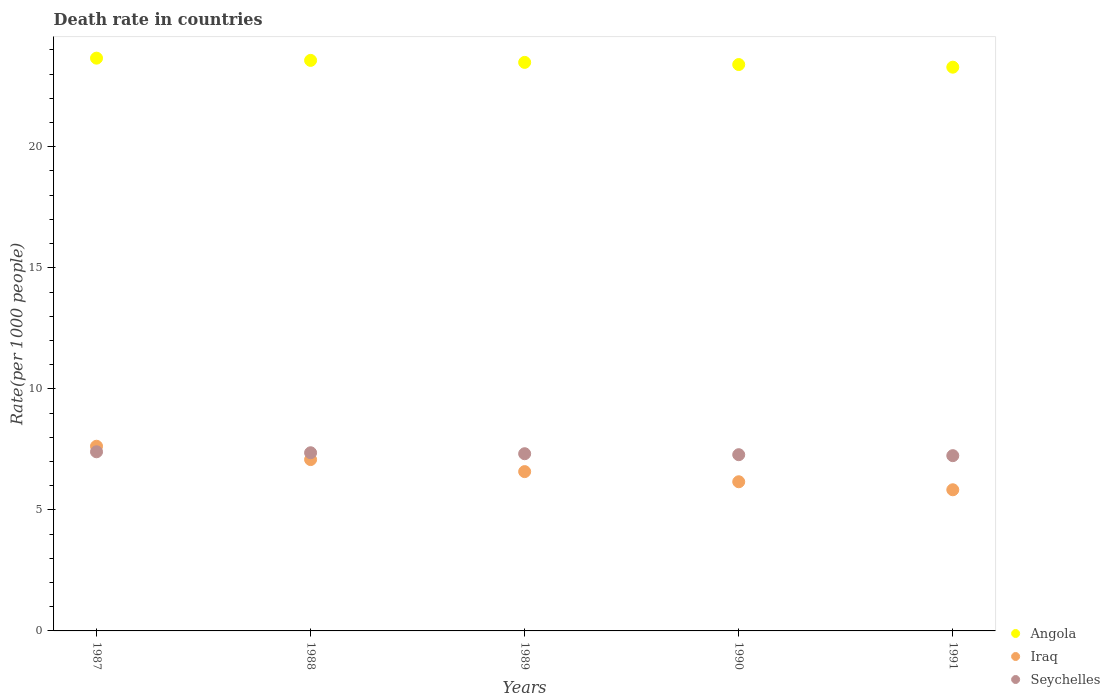Is the number of dotlines equal to the number of legend labels?
Your answer should be very brief. Yes. What is the death rate in Iraq in 1988?
Your response must be concise. 7.08. Across all years, what is the maximum death rate in Iraq?
Your response must be concise. 7.63. Across all years, what is the minimum death rate in Angola?
Provide a short and direct response. 23.29. In which year was the death rate in Angola maximum?
Offer a terse response. 1987. In which year was the death rate in Seychelles minimum?
Your answer should be compact. 1991. What is the total death rate in Angola in the graph?
Provide a succinct answer. 117.4. What is the difference between the death rate in Angola in 1987 and that in 1990?
Provide a succinct answer. 0.26. What is the difference between the death rate in Angola in 1990 and the death rate in Iraq in 1987?
Provide a short and direct response. 15.77. What is the average death rate in Angola per year?
Your answer should be compact. 23.48. In the year 1990, what is the difference between the death rate in Iraq and death rate in Angola?
Your response must be concise. -17.23. In how many years, is the death rate in Seychelles greater than 14?
Your answer should be compact. 0. What is the ratio of the death rate in Seychelles in 1989 to that in 1991?
Give a very brief answer. 1.01. Is the difference between the death rate in Iraq in 1987 and 1991 greater than the difference between the death rate in Angola in 1987 and 1991?
Give a very brief answer. Yes. What is the difference between the highest and the second highest death rate in Angola?
Give a very brief answer. 0.09. What is the difference between the highest and the lowest death rate in Angola?
Provide a succinct answer. 0.37. Is the sum of the death rate in Seychelles in 1987 and 1989 greater than the maximum death rate in Iraq across all years?
Offer a terse response. Yes. Is the death rate in Angola strictly greater than the death rate in Seychelles over the years?
Offer a very short reply. Yes. Is the death rate in Angola strictly less than the death rate in Iraq over the years?
Keep it short and to the point. No. How many years are there in the graph?
Provide a short and direct response. 5. Does the graph contain any zero values?
Your answer should be compact. No. Does the graph contain grids?
Provide a succinct answer. No. Where does the legend appear in the graph?
Offer a very short reply. Bottom right. What is the title of the graph?
Provide a short and direct response. Death rate in countries. What is the label or title of the X-axis?
Your response must be concise. Years. What is the label or title of the Y-axis?
Keep it short and to the point. Rate(per 1000 people). What is the Rate(per 1000 people) in Angola in 1987?
Provide a short and direct response. 23.66. What is the Rate(per 1000 people) of Iraq in 1987?
Ensure brevity in your answer.  7.63. What is the Rate(per 1000 people) in Angola in 1988?
Your answer should be compact. 23.57. What is the Rate(per 1000 people) in Iraq in 1988?
Offer a very short reply. 7.08. What is the Rate(per 1000 people) in Seychelles in 1988?
Offer a terse response. 7.36. What is the Rate(per 1000 people) of Angola in 1989?
Your answer should be very brief. 23.49. What is the Rate(per 1000 people) in Iraq in 1989?
Provide a short and direct response. 6.58. What is the Rate(per 1000 people) in Seychelles in 1989?
Offer a very short reply. 7.32. What is the Rate(per 1000 people) in Angola in 1990?
Provide a short and direct response. 23.4. What is the Rate(per 1000 people) in Iraq in 1990?
Give a very brief answer. 6.16. What is the Rate(per 1000 people) in Seychelles in 1990?
Provide a succinct answer. 7.28. What is the Rate(per 1000 people) of Angola in 1991?
Offer a terse response. 23.29. What is the Rate(per 1000 people) of Iraq in 1991?
Keep it short and to the point. 5.83. What is the Rate(per 1000 people) of Seychelles in 1991?
Give a very brief answer. 7.24. Across all years, what is the maximum Rate(per 1000 people) in Angola?
Your response must be concise. 23.66. Across all years, what is the maximum Rate(per 1000 people) in Iraq?
Keep it short and to the point. 7.63. Across all years, what is the maximum Rate(per 1000 people) in Seychelles?
Keep it short and to the point. 7.4. Across all years, what is the minimum Rate(per 1000 people) of Angola?
Give a very brief answer. 23.29. Across all years, what is the minimum Rate(per 1000 people) in Iraq?
Offer a terse response. 5.83. Across all years, what is the minimum Rate(per 1000 people) of Seychelles?
Your answer should be very brief. 7.24. What is the total Rate(per 1000 people) in Angola in the graph?
Ensure brevity in your answer.  117.4. What is the total Rate(per 1000 people) in Iraq in the graph?
Your answer should be compact. 33.28. What is the total Rate(per 1000 people) of Seychelles in the graph?
Offer a terse response. 36.6. What is the difference between the Rate(per 1000 people) of Angola in 1987 and that in 1988?
Provide a short and direct response. 0.09. What is the difference between the Rate(per 1000 people) of Iraq in 1987 and that in 1988?
Your answer should be very brief. 0.55. What is the difference between the Rate(per 1000 people) of Seychelles in 1987 and that in 1988?
Ensure brevity in your answer.  0.04. What is the difference between the Rate(per 1000 people) of Angola in 1987 and that in 1989?
Make the answer very short. 0.17. What is the difference between the Rate(per 1000 people) of Iraq in 1987 and that in 1989?
Your response must be concise. 1.05. What is the difference between the Rate(per 1000 people) of Seychelles in 1987 and that in 1989?
Your response must be concise. 0.08. What is the difference between the Rate(per 1000 people) of Angola in 1987 and that in 1990?
Give a very brief answer. 0.26. What is the difference between the Rate(per 1000 people) in Iraq in 1987 and that in 1990?
Provide a succinct answer. 1.47. What is the difference between the Rate(per 1000 people) of Seychelles in 1987 and that in 1990?
Give a very brief answer. 0.12. What is the difference between the Rate(per 1000 people) in Angola in 1987 and that in 1991?
Provide a short and direct response. 0.37. What is the difference between the Rate(per 1000 people) of Iraq in 1987 and that in 1991?
Provide a succinct answer. 1.8. What is the difference between the Rate(per 1000 people) of Seychelles in 1987 and that in 1991?
Offer a very short reply. 0.16. What is the difference between the Rate(per 1000 people) of Angola in 1988 and that in 1989?
Provide a succinct answer. 0.08. What is the difference between the Rate(per 1000 people) of Iraq in 1988 and that in 1989?
Make the answer very short. 0.5. What is the difference between the Rate(per 1000 people) of Angola in 1988 and that in 1990?
Provide a short and direct response. 0.17. What is the difference between the Rate(per 1000 people) in Iraq in 1988 and that in 1990?
Your response must be concise. 0.92. What is the difference between the Rate(per 1000 people) of Angola in 1988 and that in 1991?
Make the answer very short. 0.28. What is the difference between the Rate(per 1000 people) in Iraq in 1988 and that in 1991?
Keep it short and to the point. 1.25. What is the difference between the Rate(per 1000 people) in Seychelles in 1988 and that in 1991?
Offer a very short reply. 0.12. What is the difference between the Rate(per 1000 people) of Angola in 1989 and that in 1990?
Your response must be concise. 0.09. What is the difference between the Rate(per 1000 people) of Iraq in 1989 and that in 1990?
Provide a short and direct response. 0.42. What is the difference between the Rate(per 1000 people) in Seychelles in 1989 and that in 1990?
Offer a terse response. 0.04. What is the difference between the Rate(per 1000 people) in Angola in 1989 and that in 1991?
Offer a terse response. 0.2. What is the difference between the Rate(per 1000 people) in Angola in 1990 and that in 1991?
Give a very brief answer. 0.11. What is the difference between the Rate(per 1000 people) in Iraq in 1990 and that in 1991?
Make the answer very short. 0.33. What is the difference between the Rate(per 1000 people) in Seychelles in 1990 and that in 1991?
Your response must be concise. 0.04. What is the difference between the Rate(per 1000 people) in Angola in 1987 and the Rate(per 1000 people) in Iraq in 1988?
Offer a terse response. 16.58. What is the difference between the Rate(per 1000 people) of Angola in 1987 and the Rate(per 1000 people) of Seychelles in 1988?
Ensure brevity in your answer.  16.3. What is the difference between the Rate(per 1000 people) of Iraq in 1987 and the Rate(per 1000 people) of Seychelles in 1988?
Make the answer very short. 0.27. What is the difference between the Rate(per 1000 people) of Angola in 1987 and the Rate(per 1000 people) of Iraq in 1989?
Your response must be concise. 17.08. What is the difference between the Rate(per 1000 people) of Angola in 1987 and the Rate(per 1000 people) of Seychelles in 1989?
Your answer should be compact. 16.34. What is the difference between the Rate(per 1000 people) in Iraq in 1987 and the Rate(per 1000 people) in Seychelles in 1989?
Provide a succinct answer. 0.31. What is the difference between the Rate(per 1000 people) of Angola in 1987 and the Rate(per 1000 people) of Iraq in 1990?
Your response must be concise. 17.5. What is the difference between the Rate(per 1000 people) of Angola in 1987 and the Rate(per 1000 people) of Seychelles in 1990?
Keep it short and to the point. 16.38. What is the difference between the Rate(per 1000 people) in Iraq in 1987 and the Rate(per 1000 people) in Seychelles in 1990?
Your answer should be compact. 0.35. What is the difference between the Rate(per 1000 people) of Angola in 1987 and the Rate(per 1000 people) of Iraq in 1991?
Your answer should be very brief. 17.83. What is the difference between the Rate(per 1000 people) in Angola in 1987 and the Rate(per 1000 people) in Seychelles in 1991?
Provide a short and direct response. 16.42. What is the difference between the Rate(per 1000 people) of Iraq in 1987 and the Rate(per 1000 people) of Seychelles in 1991?
Your answer should be very brief. 0.39. What is the difference between the Rate(per 1000 people) in Angola in 1988 and the Rate(per 1000 people) in Iraq in 1989?
Keep it short and to the point. 16.99. What is the difference between the Rate(per 1000 people) in Angola in 1988 and the Rate(per 1000 people) in Seychelles in 1989?
Give a very brief answer. 16.25. What is the difference between the Rate(per 1000 people) in Iraq in 1988 and the Rate(per 1000 people) in Seychelles in 1989?
Your answer should be very brief. -0.24. What is the difference between the Rate(per 1000 people) in Angola in 1988 and the Rate(per 1000 people) in Iraq in 1990?
Your answer should be compact. 17.41. What is the difference between the Rate(per 1000 people) of Angola in 1988 and the Rate(per 1000 people) of Seychelles in 1990?
Give a very brief answer. 16.29. What is the difference between the Rate(per 1000 people) of Iraq in 1988 and the Rate(per 1000 people) of Seychelles in 1990?
Give a very brief answer. -0.2. What is the difference between the Rate(per 1000 people) in Angola in 1988 and the Rate(per 1000 people) in Iraq in 1991?
Offer a very short reply. 17.74. What is the difference between the Rate(per 1000 people) of Angola in 1988 and the Rate(per 1000 people) of Seychelles in 1991?
Offer a very short reply. 16.33. What is the difference between the Rate(per 1000 people) in Iraq in 1988 and the Rate(per 1000 people) in Seychelles in 1991?
Provide a short and direct response. -0.16. What is the difference between the Rate(per 1000 people) in Angola in 1989 and the Rate(per 1000 people) in Iraq in 1990?
Your answer should be compact. 17.32. What is the difference between the Rate(per 1000 people) of Angola in 1989 and the Rate(per 1000 people) of Seychelles in 1990?
Your response must be concise. 16.21. What is the difference between the Rate(per 1000 people) of Iraq in 1989 and the Rate(per 1000 people) of Seychelles in 1990?
Your answer should be very brief. -0.7. What is the difference between the Rate(per 1000 people) of Angola in 1989 and the Rate(per 1000 people) of Iraq in 1991?
Your answer should be very brief. 17.66. What is the difference between the Rate(per 1000 people) of Angola in 1989 and the Rate(per 1000 people) of Seychelles in 1991?
Your response must be concise. 16.25. What is the difference between the Rate(per 1000 people) of Iraq in 1989 and the Rate(per 1000 people) of Seychelles in 1991?
Provide a succinct answer. -0.66. What is the difference between the Rate(per 1000 people) in Angola in 1990 and the Rate(per 1000 people) in Iraq in 1991?
Your answer should be compact. 17.57. What is the difference between the Rate(per 1000 people) of Angola in 1990 and the Rate(per 1000 people) of Seychelles in 1991?
Your answer should be compact. 16.16. What is the difference between the Rate(per 1000 people) in Iraq in 1990 and the Rate(per 1000 people) in Seychelles in 1991?
Make the answer very short. -1.08. What is the average Rate(per 1000 people) of Angola per year?
Your answer should be very brief. 23.48. What is the average Rate(per 1000 people) in Iraq per year?
Make the answer very short. 6.66. What is the average Rate(per 1000 people) in Seychelles per year?
Ensure brevity in your answer.  7.32. In the year 1987, what is the difference between the Rate(per 1000 people) in Angola and Rate(per 1000 people) in Iraq?
Your answer should be very brief. 16.03. In the year 1987, what is the difference between the Rate(per 1000 people) of Angola and Rate(per 1000 people) of Seychelles?
Provide a succinct answer. 16.26. In the year 1987, what is the difference between the Rate(per 1000 people) in Iraq and Rate(per 1000 people) in Seychelles?
Your answer should be compact. 0.23. In the year 1988, what is the difference between the Rate(per 1000 people) in Angola and Rate(per 1000 people) in Iraq?
Offer a terse response. 16.49. In the year 1988, what is the difference between the Rate(per 1000 people) in Angola and Rate(per 1000 people) in Seychelles?
Keep it short and to the point. 16.21. In the year 1988, what is the difference between the Rate(per 1000 people) in Iraq and Rate(per 1000 people) in Seychelles?
Offer a terse response. -0.28. In the year 1989, what is the difference between the Rate(per 1000 people) of Angola and Rate(per 1000 people) of Iraq?
Make the answer very short. 16.91. In the year 1989, what is the difference between the Rate(per 1000 people) in Angola and Rate(per 1000 people) in Seychelles?
Keep it short and to the point. 16.17. In the year 1989, what is the difference between the Rate(per 1000 people) of Iraq and Rate(per 1000 people) of Seychelles?
Offer a terse response. -0.74. In the year 1990, what is the difference between the Rate(per 1000 people) of Angola and Rate(per 1000 people) of Iraq?
Your response must be concise. 17.23. In the year 1990, what is the difference between the Rate(per 1000 people) of Angola and Rate(per 1000 people) of Seychelles?
Give a very brief answer. 16.12. In the year 1990, what is the difference between the Rate(per 1000 people) of Iraq and Rate(per 1000 people) of Seychelles?
Keep it short and to the point. -1.12. In the year 1991, what is the difference between the Rate(per 1000 people) of Angola and Rate(per 1000 people) of Iraq?
Make the answer very short. 17.46. In the year 1991, what is the difference between the Rate(per 1000 people) of Angola and Rate(per 1000 people) of Seychelles?
Give a very brief answer. 16.05. In the year 1991, what is the difference between the Rate(per 1000 people) of Iraq and Rate(per 1000 people) of Seychelles?
Offer a very short reply. -1.41. What is the ratio of the Rate(per 1000 people) in Angola in 1987 to that in 1988?
Offer a terse response. 1. What is the ratio of the Rate(per 1000 people) of Iraq in 1987 to that in 1988?
Offer a very short reply. 1.08. What is the ratio of the Rate(per 1000 people) of Seychelles in 1987 to that in 1988?
Your response must be concise. 1.01. What is the ratio of the Rate(per 1000 people) of Angola in 1987 to that in 1989?
Keep it short and to the point. 1.01. What is the ratio of the Rate(per 1000 people) in Iraq in 1987 to that in 1989?
Offer a terse response. 1.16. What is the ratio of the Rate(per 1000 people) of Seychelles in 1987 to that in 1989?
Offer a terse response. 1.01. What is the ratio of the Rate(per 1000 people) of Angola in 1987 to that in 1990?
Give a very brief answer. 1.01. What is the ratio of the Rate(per 1000 people) of Iraq in 1987 to that in 1990?
Your response must be concise. 1.24. What is the ratio of the Rate(per 1000 people) of Seychelles in 1987 to that in 1990?
Offer a terse response. 1.02. What is the ratio of the Rate(per 1000 people) of Iraq in 1987 to that in 1991?
Provide a short and direct response. 1.31. What is the ratio of the Rate(per 1000 people) of Seychelles in 1987 to that in 1991?
Offer a very short reply. 1.02. What is the ratio of the Rate(per 1000 people) in Iraq in 1988 to that in 1989?
Ensure brevity in your answer.  1.08. What is the ratio of the Rate(per 1000 people) of Angola in 1988 to that in 1990?
Give a very brief answer. 1.01. What is the ratio of the Rate(per 1000 people) of Iraq in 1988 to that in 1990?
Give a very brief answer. 1.15. What is the ratio of the Rate(per 1000 people) in Seychelles in 1988 to that in 1990?
Keep it short and to the point. 1.01. What is the ratio of the Rate(per 1000 people) of Angola in 1988 to that in 1991?
Give a very brief answer. 1.01. What is the ratio of the Rate(per 1000 people) of Iraq in 1988 to that in 1991?
Your answer should be very brief. 1.21. What is the ratio of the Rate(per 1000 people) of Seychelles in 1988 to that in 1991?
Your answer should be very brief. 1.02. What is the ratio of the Rate(per 1000 people) of Angola in 1989 to that in 1990?
Your answer should be very brief. 1. What is the ratio of the Rate(per 1000 people) of Iraq in 1989 to that in 1990?
Provide a succinct answer. 1.07. What is the ratio of the Rate(per 1000 people) of Angola in 1989 to that in 1991?
Offer a very short reply. 1.01. What is the ratio of the Rate(per 1000 people) in Iraq in 1989 to that in 1991?
Keep it short and to the point. 1.13. What is the ratio of the Rate(per 1000 people) in Seychelles in 1989 to that in 1991?
Provide a succinct answer. 1.01. What is the ratio of the Rate(per 1000 people) of Angola in 1990 to that in 1991?
Your answer should be compact. 1. What is the ratio of the Rate(per 1000 people) of Iraq in 1990 to that in 1991?
Make the answer very short. 1.06. What is the ratio of the Rate(per 1000 people) of Seychelles in 1990 to that in 1991?
Make the answer very short. 1.01. What is the difference between the highest and the second highest Rate(per 1000 people) of Angola?
Provide a short and direct response. 0.09. What is the difference between the highest and the second highest Rate(per 1000 people) of Iraq?
Your answer should be compact. 0.55. What is the difference between the highest and the lowest Rate(per 1000 people) of Angola?
Your answer should be very brief. 0.37. What is the difference between the highest and the lowest Rate(per 1000 people) in Iraq?
Ensure brevity in your answer.  1.8. What is the difference between the highest and the lowest Rate(per 1000 people) of Seychelles?
Your answer should be very brief. 0.16. 